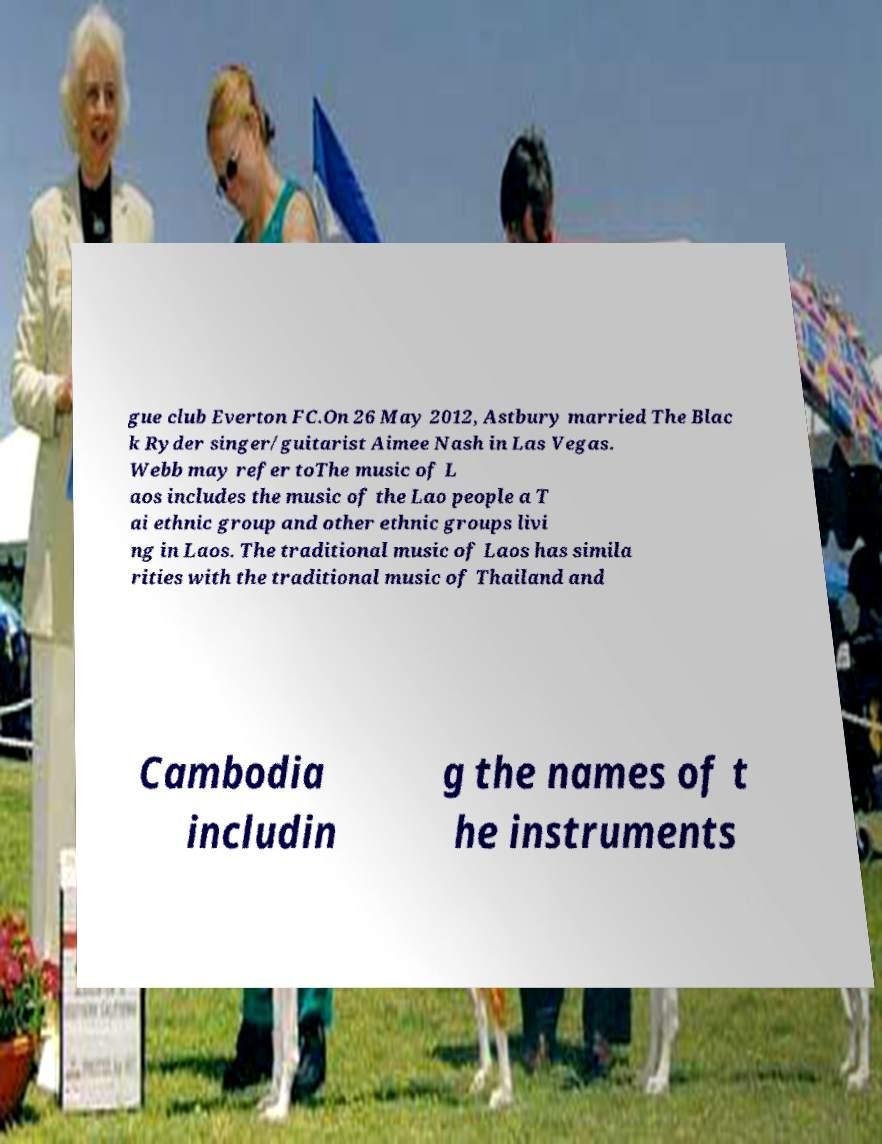There's text embedded in this image that I need extracted. Can you transcribe it verbatim? gue club Everton FC.On 26 May 2012, Astbury married The Blac k Ryder singer/guitarist Aimee Nash in Las Vegas. Webb may refer toThe music of L aos includes the music of the Lao people a T ai ethnic group and other ethnic groups livi ng in Laos. The traditional music of Laos has simila rities with the traditional music of Thailand and Cambodia includin g the names of t he instruments 